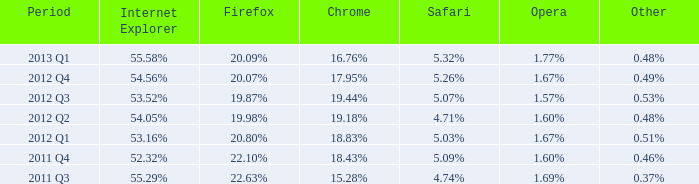What safari occurred in the fourth quarter of 2012? 5.26%. 